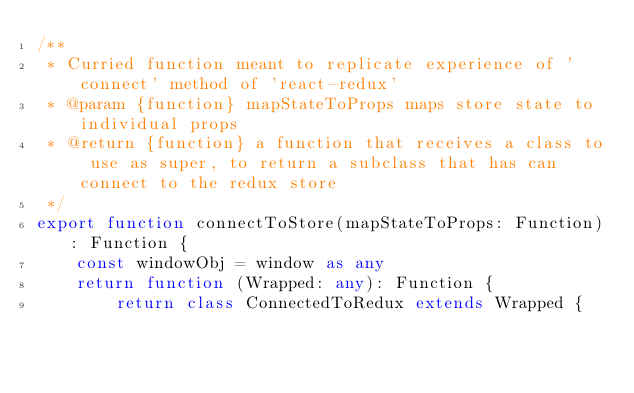Convert code to text. <code><loc_0><loc_0><loc_500><loc_500><_TypeScript_>/**
 * Curried function meant to replicate experience of 'connect' method of 'react-redux'
 * @param {function} mapStateToProps maps store state to individual props
 * @return {function} a function that receives a class to use as super, to return a subclass that has can connect to the redux store
 */
export function connectToStore(mapStateToProps: Function): Function {
	const windowObj = window as any
	return function (Wrapped: any): Function {
		return class ConnectedToRedux extends Wrapped {								</code> 